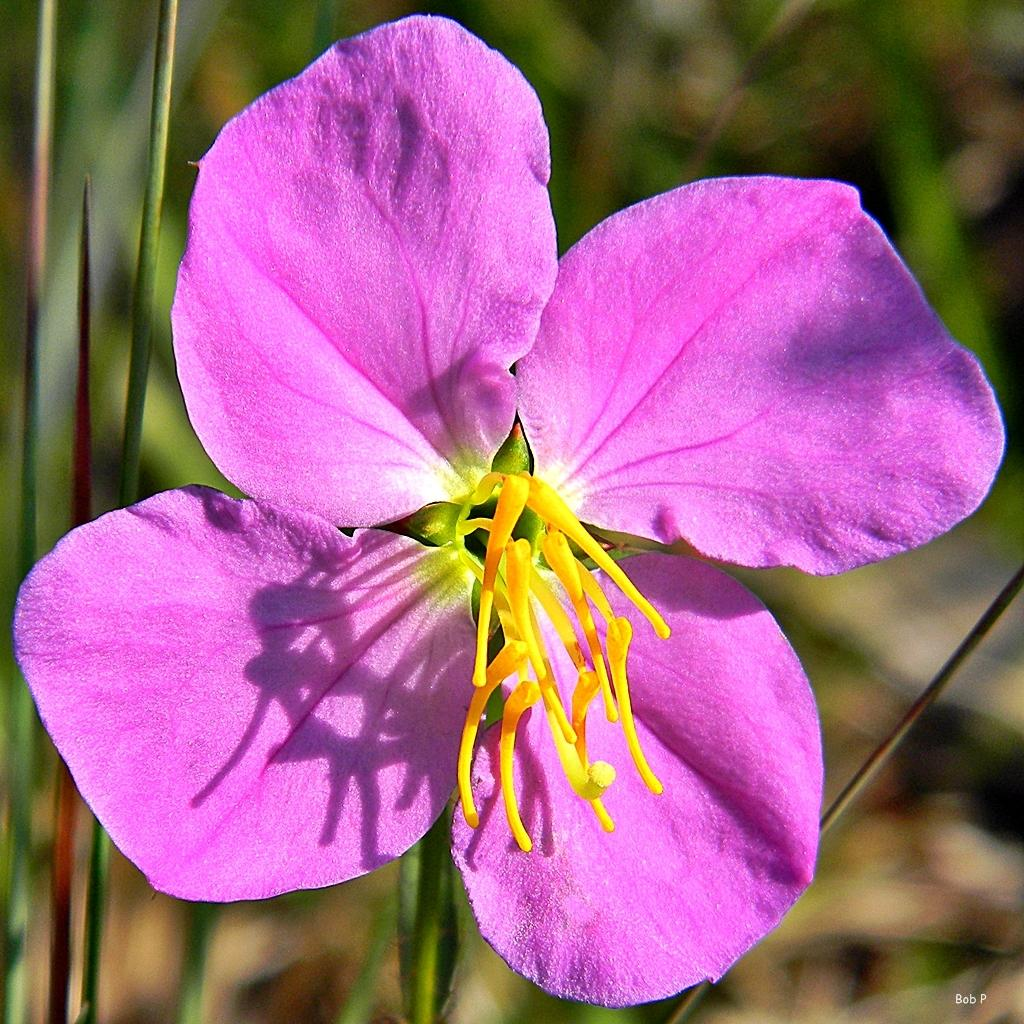What is the main subject of the image? There is a flower in the image. What color is the flower? The flower is violet in color. Can you describe the background of the image? The background of the image appears blurry. Is there any additional information or markings in the image? Yes, there is a watermark in the bottom right corner of the image. How many servants are attending to the flower in the image? There are no servants present in the image; it only features a flower. What type of zephyr can be seen blowing on the flower in the image? There is no zephyr present in the image; it is a still image of a flower. 